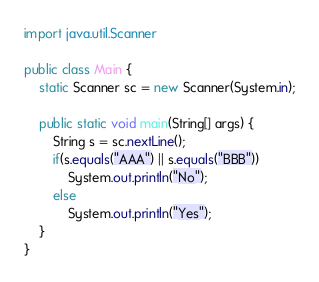<code> <loc_0><loc_0><loc_500><loc_500><_Java_>import java.util.Scanner

public class Main {
	static Scanner sc = new Scanner(System.in);
    
    public static void main(String[] args) {
    	String s = sc.nextLine();
        if(s.equals("AAA") || s.equals("BBB"))
        	System.out.println("No");
        else
        	System.out.println("Yes");
    }
}</code> 